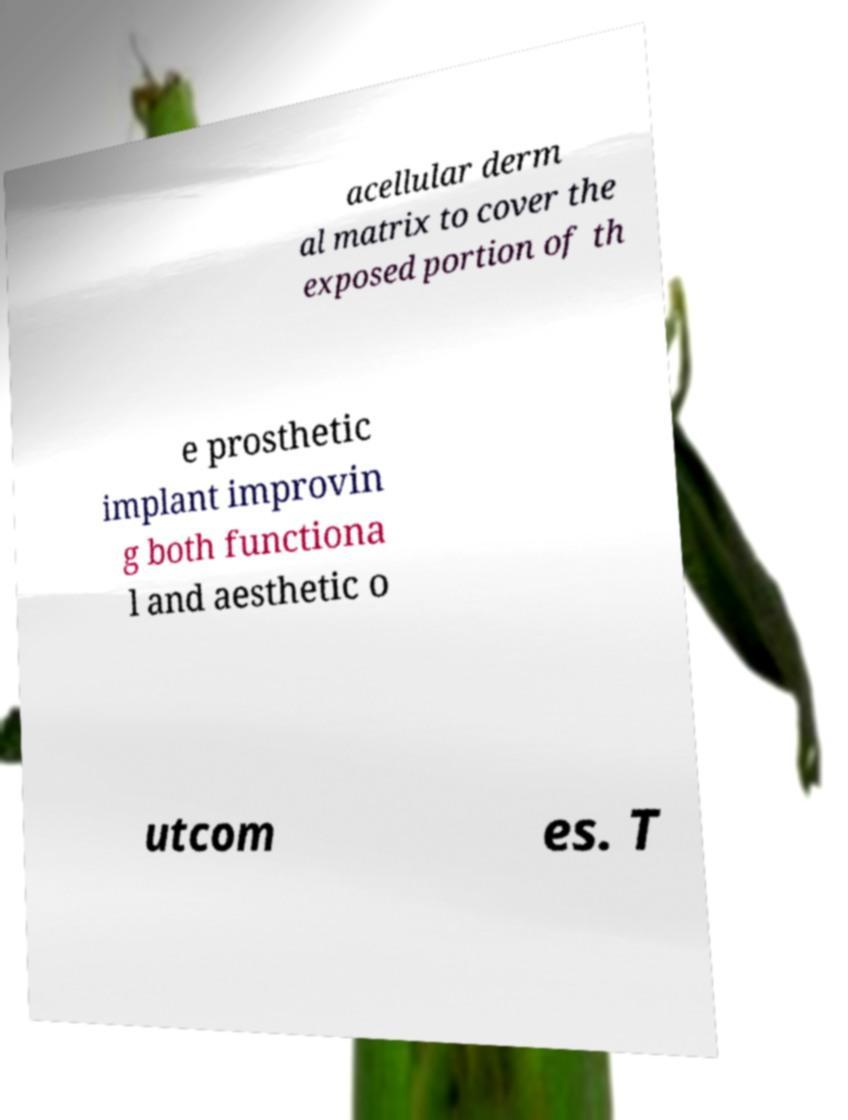For documentation purposes, I need the text within this image transcribed. Could you provide that? acellular derm al matrix to cover the exposed portion of th e prosthetic implant improvin g both functiona l and aesthetic o utcom es. T 